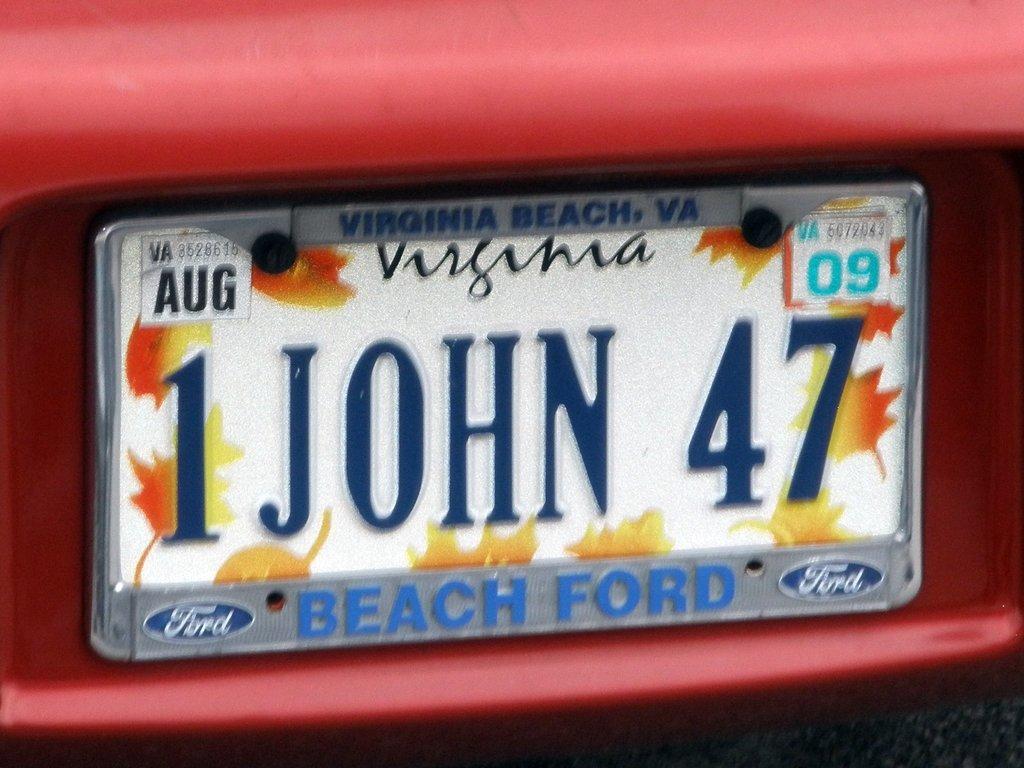Describe this image in one or two sentences. In this image there is a board with some text and numbers written on it which is on the object which is red in colour. 